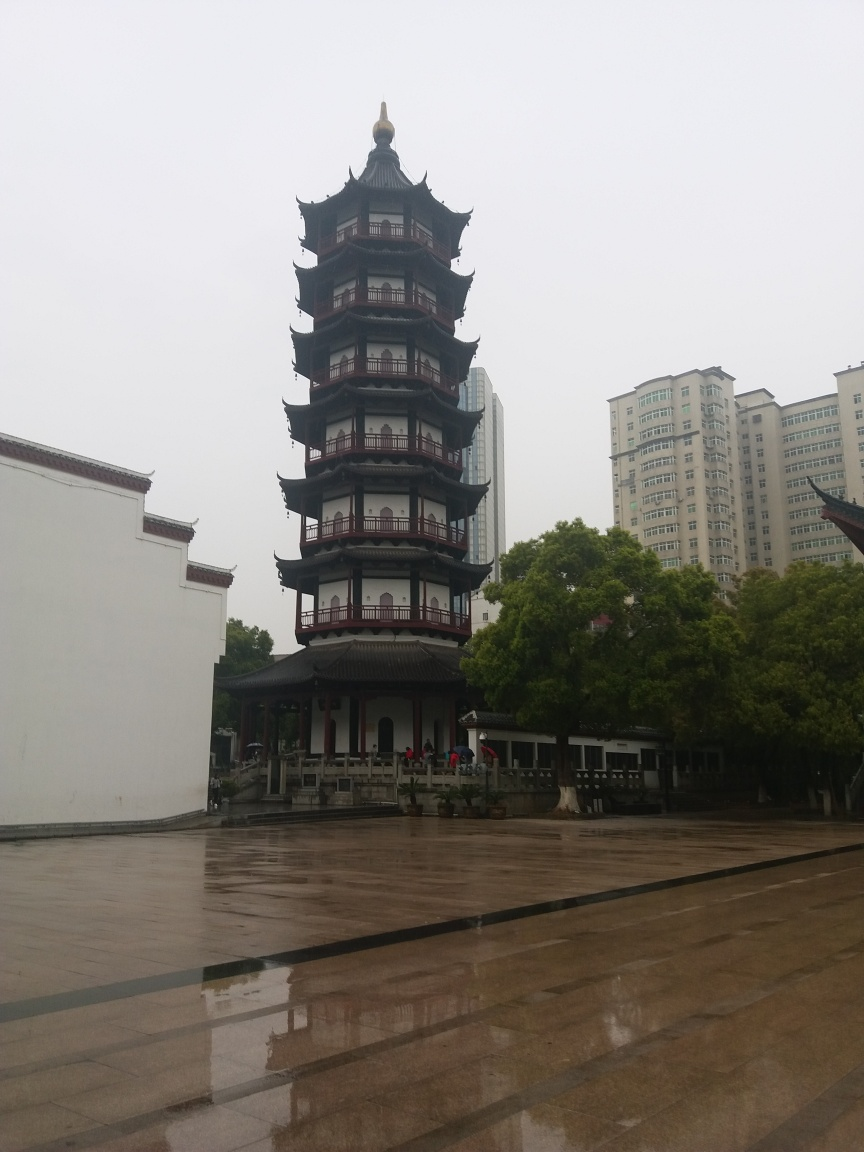Are there any exposure issues in the image? While the overall exposure of the image seems balanced, it appears slightly underexposed, causing some loss of detail in the darker areas, such as under the eaves of the pagoda and in the trees. This underexposure tends to make the image look a bit flat and can affect the visibility of finer details. Given the overcast sky, the lighting conditions didn't provide much contrast, which could have been countered with exposure compensation. 